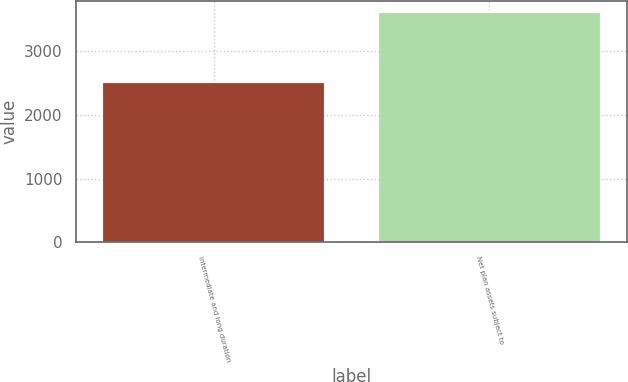Convert chart to OTSL. <chart><loc_0><loc_0><loc_500><loc_500><bar_chart><fcel>Intermediate and long duration<fcel>Net plan assets subject to<nl><fcel>2496<fcel>3606<nl></chart> 